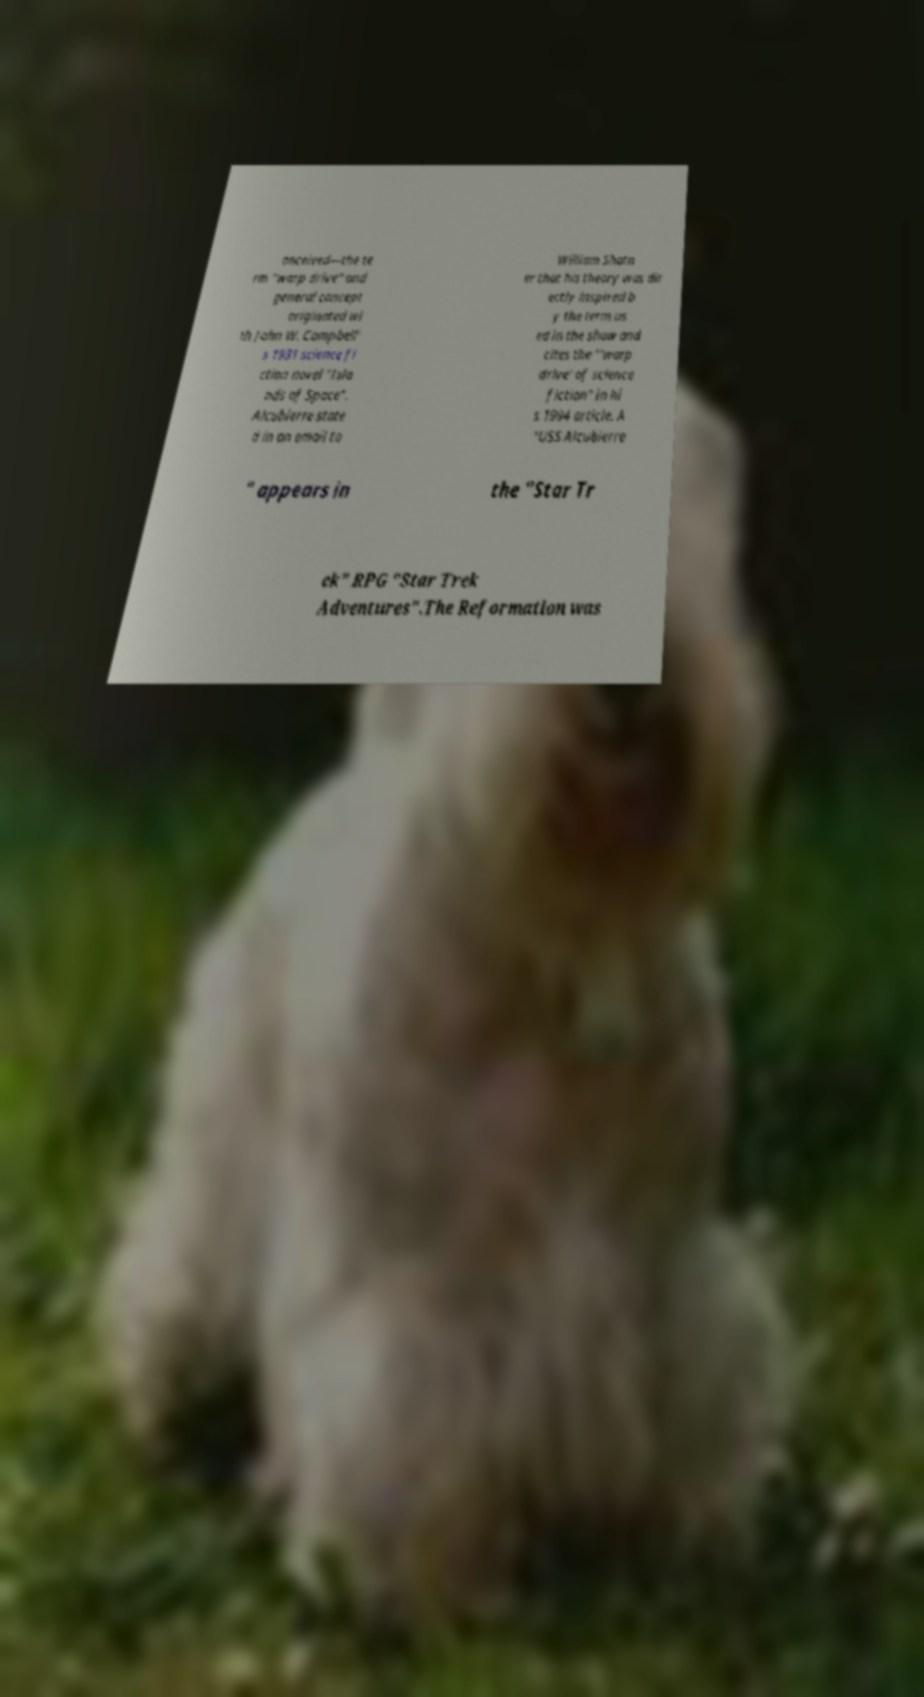What messages or text are displayed in this image? I need them in a readable, typed format. onceived—the te rm "warp drive" and general concept originated wi th John W. Campbell' s 1931 science fi ction novel "Isla nds of Space". Alcubierre state d in an email to William Shatn er that his theory was dir ectly inspired b y the term us ed in the show and cites the "'warp drive' of science fiction" in hi s 1994 article. A "USS Alcubierre " appears in the "Star Tr ek" RPG "Star Trek Adventures".The Reformation was 